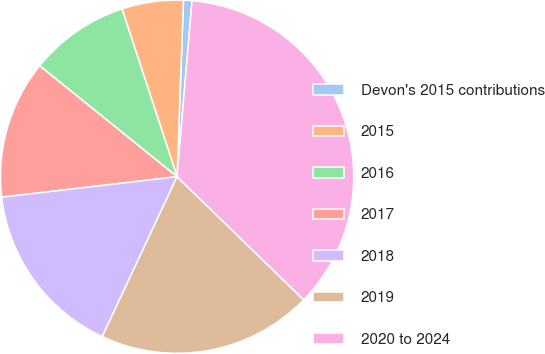Convert chart to OTSL. <chart><loc_0><loc_0><loc_500><loc_500><pie_chart><fcel>Devon's 2015 contributions<fcel>2015<fcel>2016<fcel>2017<fcel>2018<fcel>2019<fcel>2020 to 2024<nl><fcel>0.77%<fcel>5.63%<fcel>9.14%<fcel>12.66%<fcel>16.18%<fcel>19.69%<fcel>35.93%<nl></chart> 